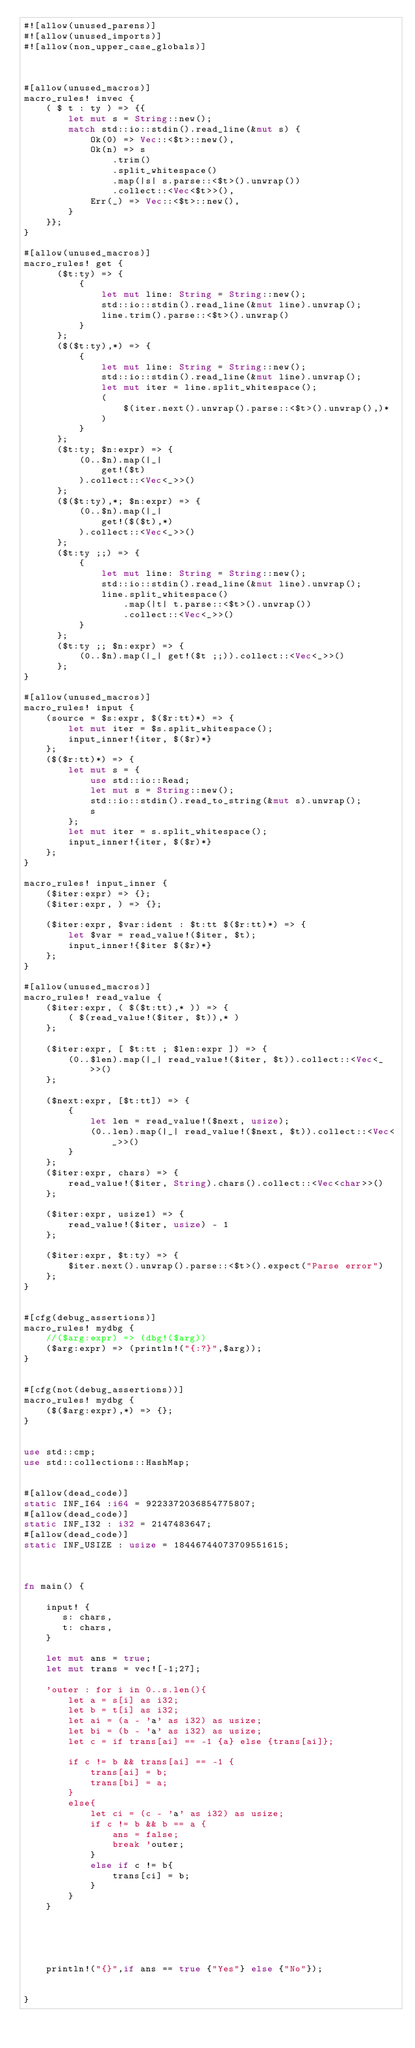<code> <loc_0><loc_0><loc_500><loc_500><_Rust_>#![allow(unused_parens)]
#![allow(unused_imports)]
#![allow(non_upper_case_globals)]



#[allow(unused_macros)]
macro_rules! invec {
    ( $ t : ty ) => {{
        let mut s = String::new();
        match std::io::stdin().read_line(&mut s) {
            Ok(0) => Vec::<$t>::new(),
            Ok(n) => s
                .trim()
                .split_whitespace()
                .map(|s| s.parse::<$t>().unwrap())
                .collect::<Vec<$t>>(),
            Err(_) => Vec::<$t>::new(),
        }
    }};
}

#[allow(unused_macros)]
macro_rules! get {
      ($t:ty) => {
          {
              let mut line: String = String::new();
              std::io::stdin().read_line(&mut line).unwrap();
              line.trim().parse::<$t>().unwrap()
          }
      };
      ($($t:ty),*) => {
          {
              let mut line: String = String::new();
              std::io::stdin().read_line(&mut line).unwrap();
              let mut iter = line.split_whitespace();
              (
                  $(iter.next().unwrap().parse::<$t>().unwrap(),)*
              )
          }
      };
      ($t:ty; $n:expr) => {
          (0..$n).map(|_|
              get!($t)
          ).collect::<Vec<_>>()
      };
      ($($t:ty),*; $n:expr) => {
          (0..$n).map(|_|
              get!($($t),*)
          ).collect::<Vec<_>>()
      };
      ($t:ty ;;) => {
          {
              let mut line: String = String::new();
              std::io::stdin().read_line(&mut line).unwrap();
              line.split_whitespace()
                  .map(|t| t.parse::<$t>().unwrap())
                  .collect::<Vec<_>>()
          }
      };
      ($t:ty ;; $n:expr) => {
          (0..$n).map(|_| get!($t ;;)).collect::<Vec<_>>()
      };
}

#[allow(unused_macros)]
macro_rules! input {
    (source = $s:expr, $($r:tt)*) => {
        let mut iter = $s.split_whitespace();
        input_inner!{iter, $($r)*}
    };
    ($($r:tt)*) => {
        let mut s = {
            use std::io::Read;
            let mut s = String::new();
            std::io::stdin().read_to_string(&mut s).unwrap();
            s
        };
        let mut iter = s.split_whitespace();
        input_inner!{iter, $($r)*}
    };
}

macro_rules! input_inner {
    ($iter:expr) => {};
    ($iter:expr, ) => {};

    ($iter:expr, $var:ident : $t:tt $($r:tt)*) => {
        let $var = read_value!($iter, $t);
        input_inner!{$iter $($r)*}
    };
}

#[allow(unused_macros)]
macro_rules! read_value {
    ($iter:expr, ( $($t:tt),* )) => {
        ( $(read_value!($iter, $t)),* )
    };

    ($iter:expr, [ $t:tt ; $len:expr ]) => {
        (0..$len).map(|_| read_value!($iter, $t)).collect::<Vec<_>>()
    };

    ($next:expr, [$t:tt]) => {
        {
            let len = read_value!($next, usize);
            (0..len).map(|_| read_value!($next, $t)).collect::<Vec<_>>()
        }
    };
    ($iter:expr, chars) => {
        read_value!($iter, String).chars().collect::<Vec<char>>()
    };

    ($iter:expr, usize1) => {
        read_value!($iter, usize) - 1
    };

    ($iter:expr, $t:ty) => {
        $iter.next().unwrap().parse::<$t>().expect("Parse error")
    };
}


#[cfg(debug_assertions)]
macro_rules! mydbg {
    //($arg:expr) => (dbg!($arg))
    ($arg:expr) => (println!("{:?}",$arg));
}


#[cfg(not(debug_assertions))]
macro_rules! mydbg {
    ($($arg:expr),*) => {};
}


use std::cmp;
use std::collections::HashMap;


#[allow(dead_code)]
static INF_I64 :i64 = 9223372036854775807;
#[allow(dead_code)]
static INF_I32 : i32 = 2147483647;
#[allow(dead_code)]
static INF_USIZE : usize = 18446744073709551615;



fn main() {

    input! { 
       s: chars,
       t: chars,
    }

    let mut ans = true;
    let mut trans = vec![-1;27];

    'outer : for i in 0..s.len(){
        let a = s[i] as i32;
        let b = t[i] as i32;
        let ai = (a - 'a' as i32) as usize;
        let bi = (b - 'a' as i32) as usize;
        let c = if trans[ai] == -1 {a} else {trans[ai]};
        
        if c != b && trans[ai] == -1 {
            trans[ai] = b;
            trans[bi] = a;
        }
        else{
            let ci = (c - 'a' as i32) as usize;
            if c != b && b == a {
                ans = false;
                break 'outer;
            }
            else if c != b{
                trans[ci] = b;
            }
        }
    }



    

    println!("{}",if ans == true {"Yes"} else {"No"});


}
</code> 